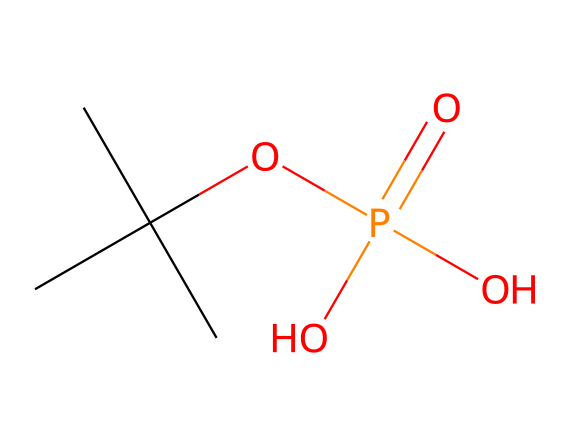What is the main functional group in this compound? The compound contains a phosphorus atom bonded to an oxygen atom via a double bond (P=O) and also has hydroxyl groups (–OH), indicating that it has a phosphoric acid functional group.
Answer: phosphoric acid How many carbon atoms are present in the structure? Counting the 'C' atoms in the SMILES representation shows there are 4 carbon atoms in the structure (3 from the branching part and 1 from the straight chain).
Answer: 4 What type of bond is represented between the phosphorus and oxygen in the P=O structure? The P=O indicates a double bond between phosphorus and oxygen, characterized by a stronger interaction compared to a single bond.
Answer: double bond What element gives the compound its phosphorus classification? The presence of the phosphorus atom ('P') in the SMILES notation classifies this compound as a phosphorus compound.
Answer: phosphorus What is the total number of oxygen atoms in this chemical? By analyzing the structure, there are a total of 4 oxygen atoms: one in the P=O group and three in the hydroxyl (-OH) groups.
Answer: 4 Is this compound likely to be polar or nonpolar? Considering the presence of multiple hydroxyl groups (–OH) which can form hydrogen bonds, this compound is likely to be polar.
Answer: polar What is the degree of saturation in this compound? The molecule contains a double bond and no rings, indicating that it has a degree of saturation that allows for considering the unsaturation from the double bond alongside the single bonds in the structure.
Answer: saturated 